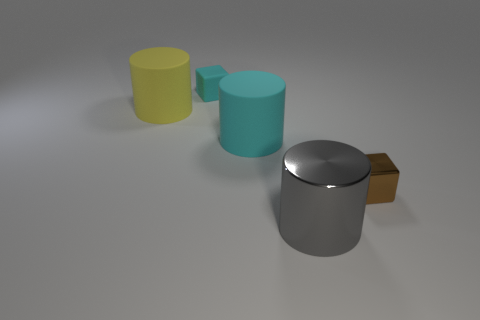How many gray cylinders are the same size as the yellow rubber cylinder?
Give a very brief answer. 1. Are there fewer tiny metallic objects that are in front of the gray shiny thing than tiny brown metallic objects?
Offer a very short reply. Yes. There is a rubber cylinder on the right side of the large yellow cylinder that is behind the large cyan rubber cylinder; what size is it?
Offer a terse response. Large. How many things are brown metal blocks or large cylinders?
Make the answer very short. 4. Are there any other small rubber things that have the same color as the tiny rubber thing?
Provide a succinct answer. No. Are there fewer large blue cubes than big things?
Your answer should be compact. Yes. What number of things are red metal blocks or cylinders in front of the tiny brown metallic cube?
Provide a short and direct response. 1. Is there a yellow object that has the same material as the brown object?
Offer a terse response. No. There is another cube that is the same size as the cyan rubber cube; what is its material?
Your response must be concise. Metal. There is a cylinder that is to the left of the block that is behind the tiny brown object; what is it made of?
Provide a succinct answer. Rubber. 